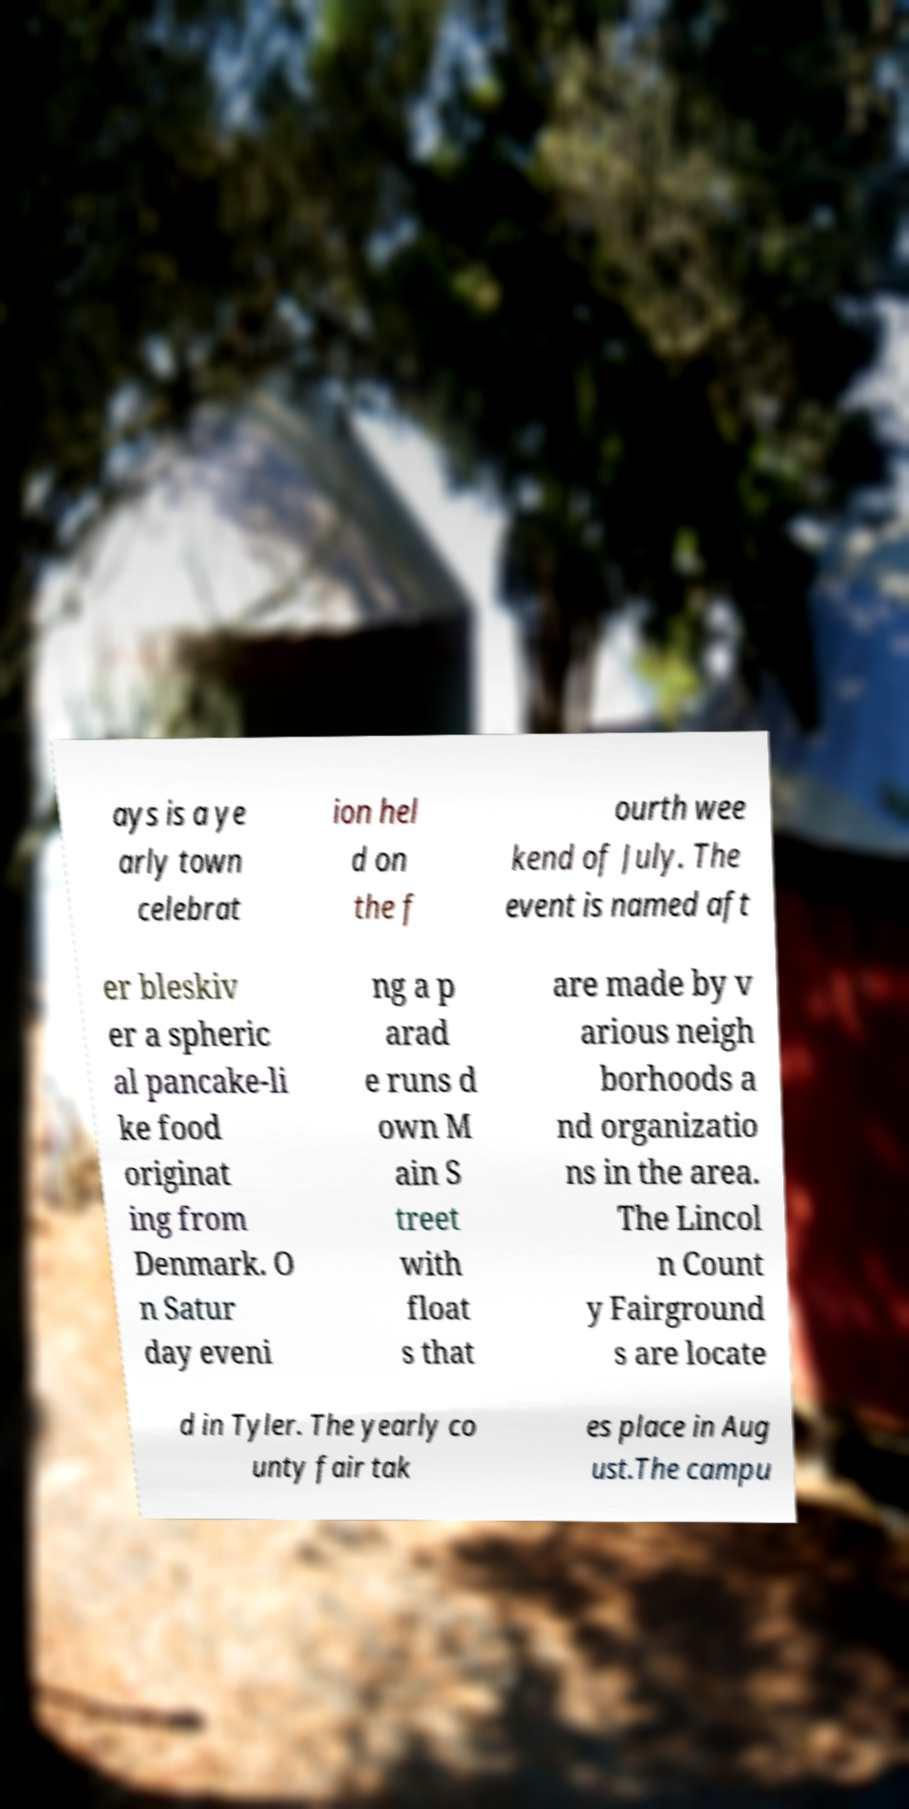Please identify and transcribe the text found in this image. ays is a ye arly town celebrat ion hel d on the f ourth wee kend of July. The event is named aft er bleskiv er a spheric al pancake-li ke food originat ing from Denmark. O n Satur day eveni ng a p arad e runs d own M ain S treet with float s that are made by v arious neigh borhoods a nd organizatio ns in the area. The Lincol n Count y Fairground s are locate d in Tyler. The yearly co unty fair tak es place in Aug ust.The campu 